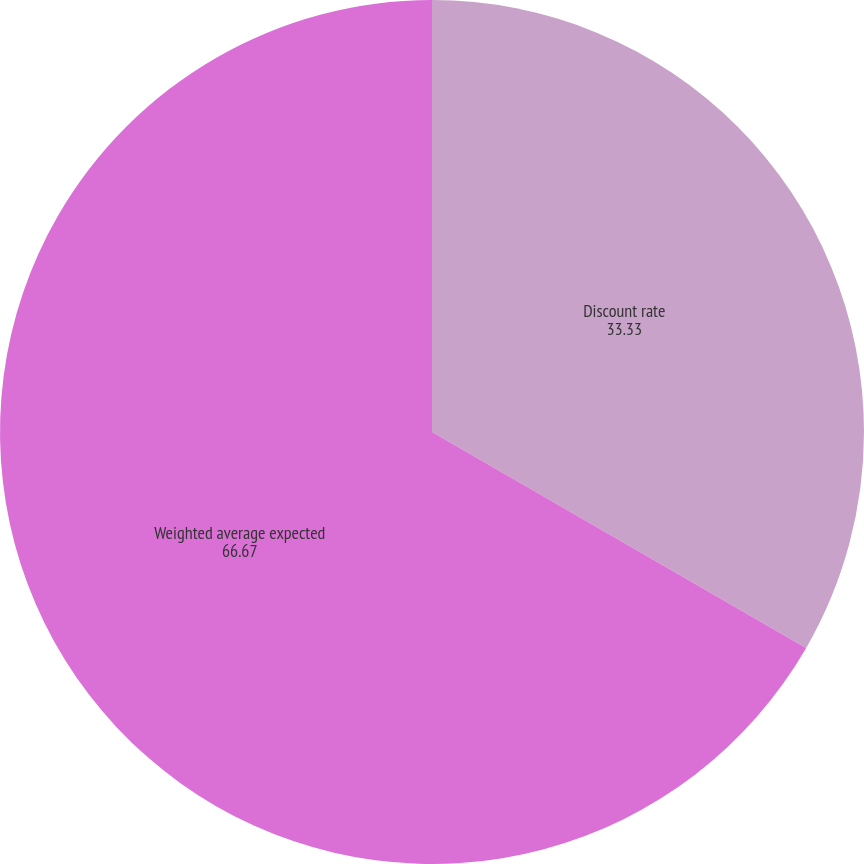Convert chart. <chart><loc_0><loc_0><loc_500><loc_500><pie_chart><fcel>Discount rate<fcel>Weighted average expected<nl><fcel>33.33%<fcel>66.67%<nl></chart> 